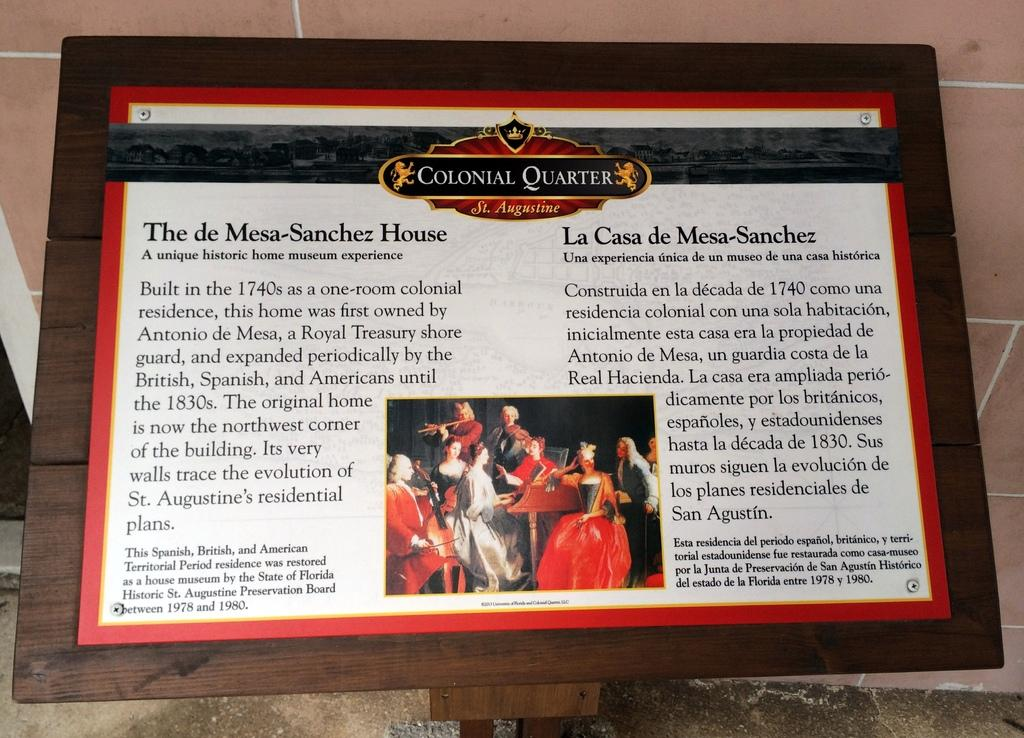Provide a one-sentence caption for the provided image. Colonial Quarter is sharing information in text about the Mesa-Sanchez house. 